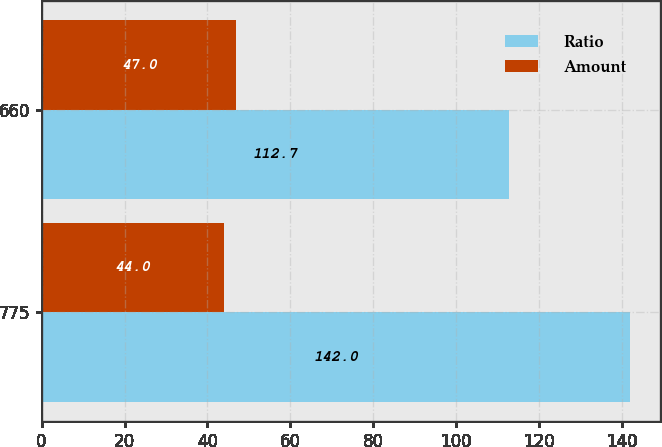Convert chart to OTSL. <chart><loc_0><loc_0><loc_500><loc_500><stacked_bar_chart><ecel><fcel>775<fcel>660<nl><fcel>Ratio<fcel>142<fcel>112.7<nl><fcel>Amount<fcel>44<fcel>47<nl></chart> 